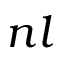Convert formula to latex. <formula><loc_0><loc_0><loc_500><loc_500>n l</formula> 